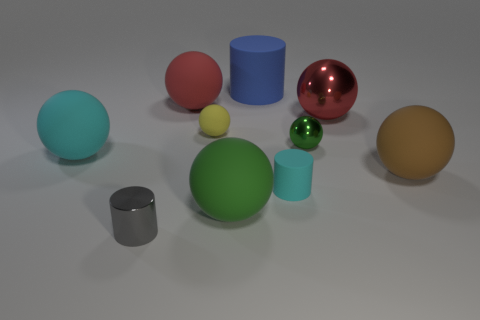Can you count the number of spheres in the image? Yes, there are five spheres in total in the image. Which sphere is the largest? The largest sphere in the image is the green one. 